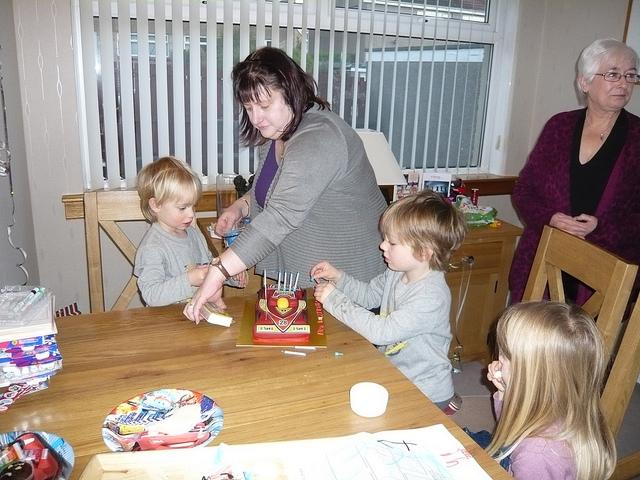How many women are wearing glasses?
Write a very short answer. 1. What birthday is this?
Short answer required. Boy. How many kids are there?
Quick response, please. 3. Whose birthday is it?
Concise answer only. Boys. 